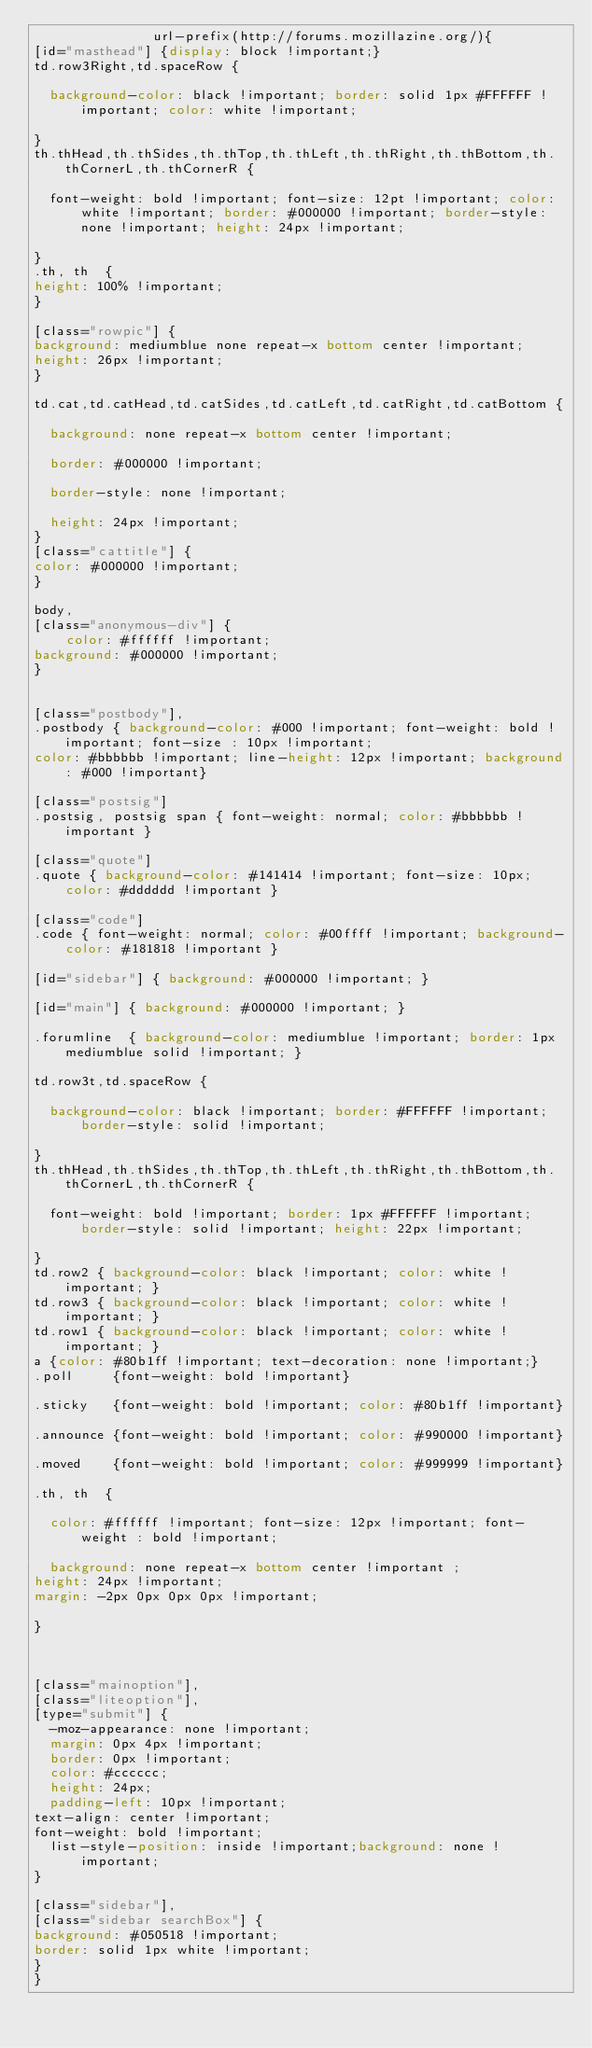<code> <loc_0><loc_0><loc_500><loc_500><_CSS_>               url-prefix(http://forums.mozillazine.org/){
[id="masthead"] {display: block !important;}
td.row3Right,td.spaceRow {

  background-color: black !important; border: solid 1px #FFFFFF !important; color: white !important;

}
th.thHead,th.thSides,th.thTop,th.thLeft,th.thRight,th.thBottom,th.thCornerL,th.thCornerR {

  font-weight: bold !important; font-size: 12pt !important; color: white !important; border: #000000 !important; border-style: none !important; height: 24px !important;

}
.th, th  {
height: 100% !important;
}

[class="rowpic"] {
background: mediumblue none repeat-x bottom center !important;
height: 26px !important;
}

td.cat,td.catHead,td.catSides,td.catLeft,td.catRight,td.catBottom {

  background: none repeat-x bottom center !important;

  border: #000000 !important;

  border-style: none !important;

  height: 24px !important;
}
[class="cattitle"] {
color: #000000 !important;
}

body,
[class="anonymous-div"] {
    color: #ffffff !important;
background: #000000 !important;
}


[class="postbody"],
.postbody { background-color: #000 !important; font-weight: bold !important; font-size : 10px !important;
color: #bbbbbb !important; line-height: 12px !important; background: #000 !important}

[class="postsig"]
.postsig, postsig span { font-weight: normal; color: #bbbbbb !important }

[class="quote"]
.quote { background-color: #141414 !important; font-size: 10px; color: #dddddd !important }

[class="code"]
.code { font-weight: normal; color: #00ffff !important; background-color: #181818 !important }

[id="sidebar"] { background: #000000 !important; }

[id="main"] { background: #000000 !important; }

.forumline  { background-color: mediumblue !important; border: 1px mediumblue solid !important; }

td.row3t,td.spaceRow {

  background-color: black !important; border: #FFFFFF !important; border-style: solid !important;

}
th.thHead,th.thSides,th.thTop,th.thLeft,th.thRight,th.thBottom,th.thCornerL,th.thCornerR {

  font-weight: bold !important; border: 1px #FFFFFF !important; border-style: solid !important; height: 22px !important;

}
td.row2 { background-color: black !important; color: white !important; }
td.row3 { background-color: black !important; color: white !important; }
td.row1 { background-color: black !important; color: white !important; }
a {color: #80b1ff !important; text-decoration: none !important;}
.poll     {font-weight: bold !important}

.sticky   {font-weight: bold !important; color: #80b1ff !important}

.announce {font-weight: bold !important; color: #990000 !important}

.moved    {font-weight: bold !important; color: #999999 !important}

.th, th  {

  color: #ffffff !important; font-size: 12px !important; font-weight : bold !important;

  background: none repeat-x bottom center !important ;
height: 24px !important;
margin: -2px 0px 0px 0px !important;

}



[class="mainoption"],
[class="liteoption"],
[type="submit"] {
  -moz-appearance: none !important;
  margin: 0px 4px !important;
  border: 0px !important;
  color: #cccccc;
  height: 24px;
  padding-left: 10px !important;
text-align: center !important;
font-weight: bold !important;
  list-style-position: inside !important;background: none !important; 
}

[class="sidebar"],
[class="sidebar searchBox"] {
background: #050518 !important;
border: solid 1px white !important;
}
}</code> 